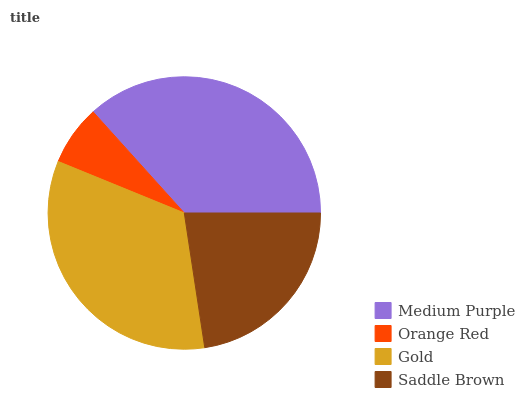Is Orange Red the minimum?
Answer yes or no. Yes. Is Medium Purple the maximum?
Answer yes or no. Yes. Is Gold the minimum?
Answer yes or no. No. Is Gold the maximum?
Answer yes or no. No. Is Gold greater than Orange Red?
Answer yes or no. Yes. Is Orange Red less than Gold?
Answer yes or no. Yes. Is Orange Red greater than Gold?
Answer yes or no. No. Is Gold less than Orange Red?
Answer yes or no. No. Is Gold the high median?
Answer yes or no. Yes. Is Saddle Brown the low median?
Answer yes or no. Yes. Is Medium Purple the high median?
Answer yes or no. No. Is Gold the low median?
Answer yes or no. No. 